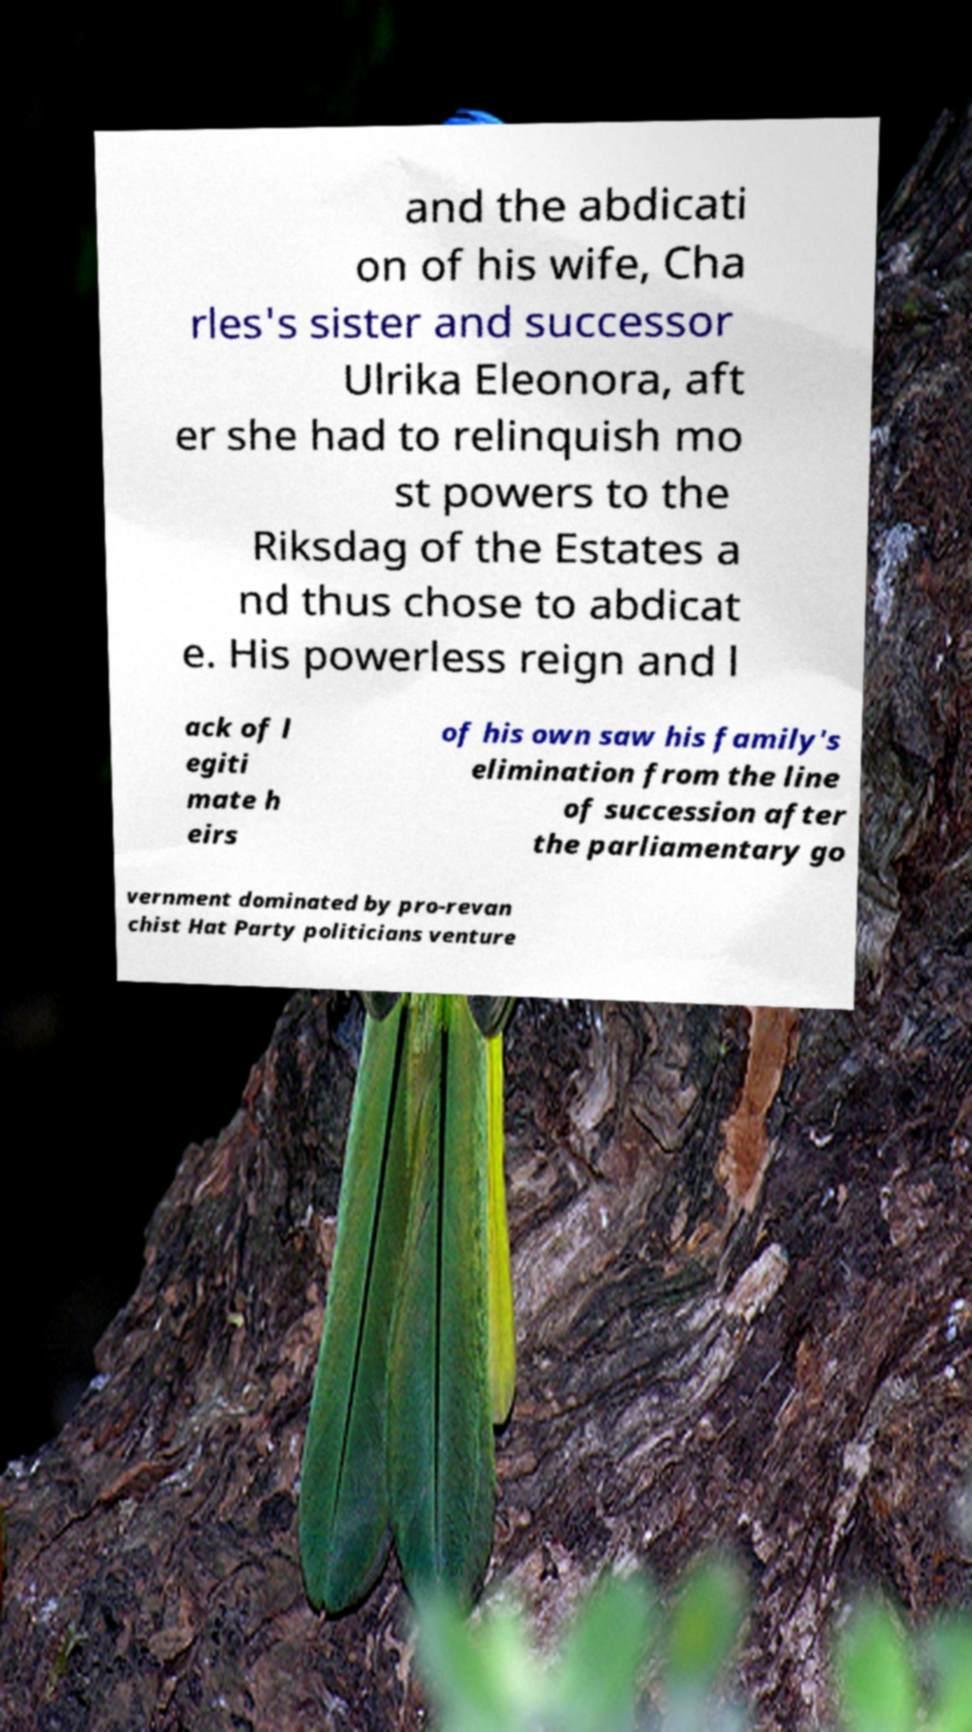Please read and relay the text visible in this image. What does it say? and the abdicati on of his wife, Cha rles's sister and successor Ulrika Eleonora, aft er she had to relinquish mo st powers to the Riksdag of the Estates a nd thus chose to abdicat e. His powerless reign and l ack of l egiti mate h eirs of his own saw his family's elimination from the line of succession after the parliamentary go vernment dominated by pro-revan chist Hat Party politicians venture 